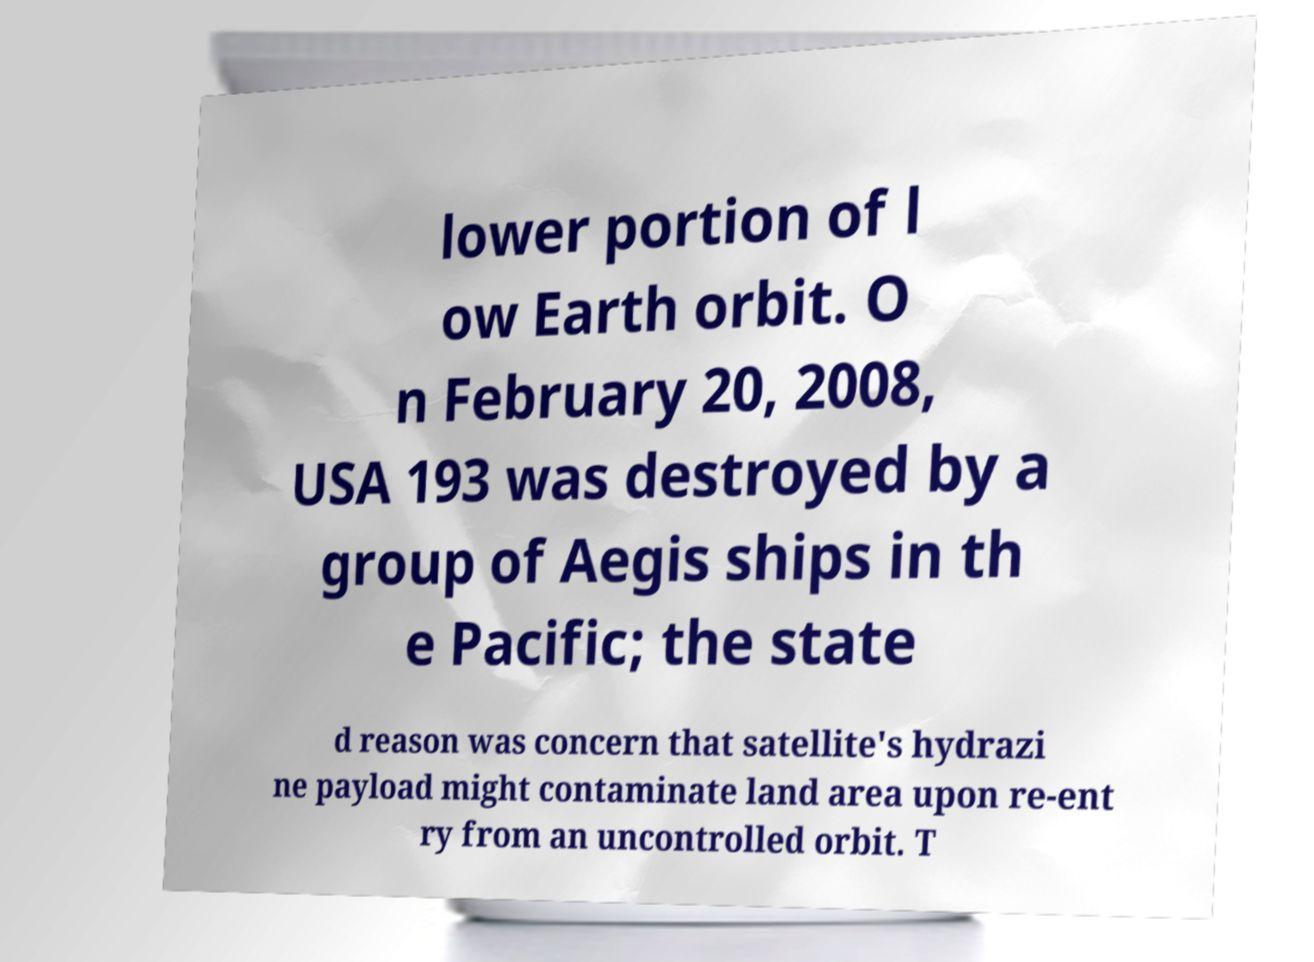Please read and relay the text visible in this image. What does it say? lower portion of l ow Earth orbit. O n February 20, 2008, USA 193 was destroyed by a group of Aegis ships in th e Pacific; the state d reason was concern that satellite's hydrazi ne payload might contaminate land area upon re-ent ry from an uncontrolled orbit. T 